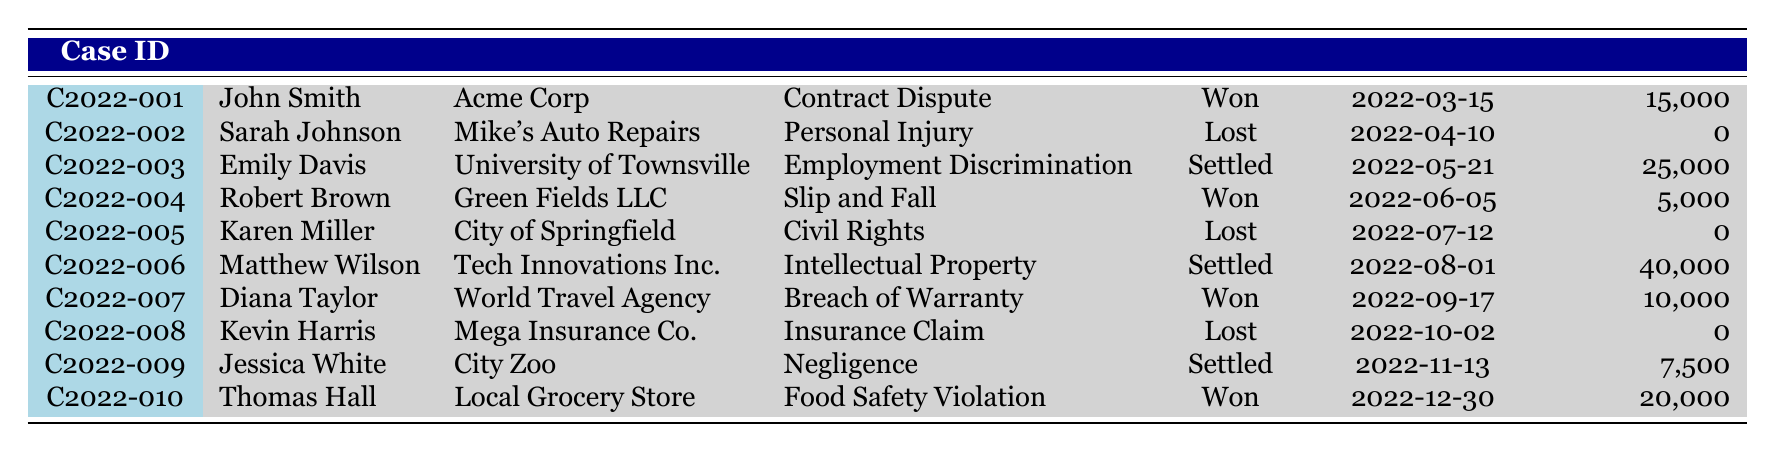What was the outcome of John Smith's case? According to the table, John Smith's case (C2022-001) had the outcome "Won."
Answer: Won How many cases were won in total? The cases with "Won" outcomes are C2022-001, C2022-004, C2022-007, and C2022-010. This gives a total of 4 won cases.
Answer: 4 What is the total amount of damages awarded in settled cases? The damages awarded in settled cases are $25,000 (C2022-003) + $40,000 (C2022-006) + $7,500 (C2022-009) = $72,500.
Answer: $72,500 Which plaintiff received the highest damages awarded? The highest damages awarded was $40,000 to Matthew Wilson in case C2022-006.
Answer: Matthew Wilson Did any civil rights cases result in a win? The civil rights case (C2022-005) by Karen Miller resulted in a "Lost" outcome. Therefore, the answer is no.
Answer: No What was the average damages awarded across all cases? The total damages awarded are $15,000 + $0 + $25,000 + $5,000 + $0 + $40,000 + $10,000 + $0 + $7,500 + $20,000 = $117,500. There are 10 cases in total, so the average is $117,500 / 10 = $11,750.
Answer: $11,750 How many cases had outcomes of "Lost"? The cases with "Lost" outcomes are C2022-002, C2022-005, and C2022-008, totaling 3 cases.
Answer: 3 What percentage of cases were settled? There are 3 settled cases out of a total of 10 cases. To calculate the percentage, (3 / 10) * 100 = 30%.
Answer: 30% How many cases involved personal injury and what were their outcomes? There was 1 personal injury case (C2022-002), and its outcome was "Lost."
Answer: 1 case, outcome: Lost Was the same judge presiding over all cases? The table indicates that all cases listed were presided over by Hon. William Carter, confirming yes.
Answer: Yes What is the difference in damages awarded between the highest and lowest case outcomes? The highest damages awarded was $40,000 (C2022-006) and the lowest was $0 (in multiple cases). Therefore, $40,000 - $0 = $40,000.
Answer: $40,000 